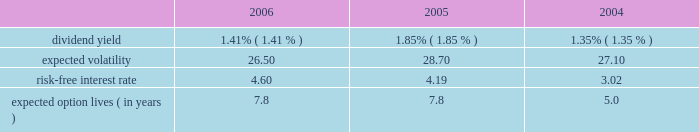For the year ended december 31 , 2005 , we realized net losses of $ 1 million on sales of available-for- sale securities .
Unrealized gains of $ 1 million were included in other comprehensive income at december 31 , 2004 , net of deferred taxes of less than $ 1 million , related to these sales .
For the year ended december 31 , 2004 , we realized net gains of $ 26 million on sales of available-for- sale securities .
Unrealized gains of $ 11 million were included in other comprehensive income at december 31 , 2003 , net of deferred taxes of $ 7 million , related to these sales .
Note 13 .
Equity-based compensation the 2006 equity incentive plan was approved by shareholders in april 2006 , and 20000000 shares of common stock were approved for issuance for stock and stock-based awards , including stock options , stock appreciation rights , restricted stock , deferred stock and performance awards .
In addition , up to 8000000 shares from our 1997 equity incentive plan , that were available to issue or become available due to cancellations and forfeitures , may be awarded under the 2006 plan .
The 1997 plan expired on december 18 , 2006 .
As of december 31 , 2006 , 1305420 shares from the 1997 plan have been added to and may be awarded from the 2006 plan .
As of december 31 , 2006 , 106045 awards have been made under the 2006 plan .
We have stock options outstanding from previous plans , including the 1997 plan , under which no further grants can be made .
The exercise price of non-qualified and incentive stock options and stock appreciation rights may not be less than the fair value of such shares at the date of grant .
Stock options and stock appreciation rights issued under the 2006 plan and the prior 1997 plan generally vest over four years and expire no later than ten years from the date of grant .
For restricted stock awards issued under the 2006 plan and the prior 1997 plan , stock certificates are issued at the time of grant and recipients have dividend and voting rights .
In general , these grants vest over three years .
For deferred stock awards issued under the 2006 plan and the prior 1997 plan , no stock is issued at the time of grant .
Generally , these grants vest over two- , three- or four-year periods .
Performance awards granted under the 2006 equity incentive plan and the prior 1997 plan are earned over a performance period based on achievement of goals , generally over two- to three- year periods .
Payment for performance awards is made in shares of our common stock or in cash equal to the fair market value of our common stock , based on certain financial ratios after the conclusion of each performance period .
We record compensation expense , equal to the estimated fair value of the options on the grant date , on a straight-line basis over the options 2019 vesting period .
We use a black-scholes option-pricing model to estimate the fair value of the options granted .
The weighted-average assumptions used in connection with the option-pricing model were as follows for the years indicated. .
Compensation expense related to stock options , stock appreciation rights , restricted stock awards , deferred stock awards and performance awards , which we record as a component of salaries and employee benefits expense in our consolidated statement of income , was $ 208 million , $ 110 million and $ 74 million for the years ended december 31 , 2006 , 2005 and 2004 , respectively .
The related total income tax benefit recorded in our consolidated statement of income was $ 83 million , $ 44 million and $ 30 million for 2006 , 2005 and 2004 , respectively .
Seq 87 copyarea : 38 .
X 54 .
Trimsize : 8.25 x 10.75 typeset state street corporation serverprocess c:\\fc\\delivery_1024177\\2771-1-do_p.pdf chksum : 0 cycle 1merrill corporation 07-2771-1 thu mar 01 17:11:13 2007 ( v 2.247w--stp1pae18 ) .
By what percent did the risk free interest rate increase between 2004 and 2006? 
Computations: ((4.60 - 3.02) / 3.02)
Answer: 0.52318. 